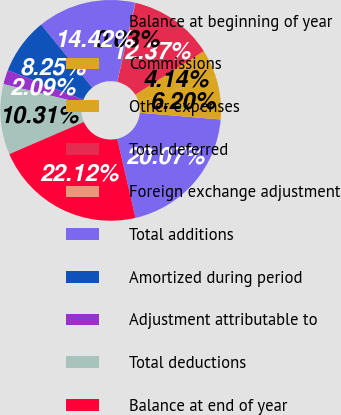Convert chart. <chart><loc_0><loc_0><loc_500><loc_500><pie_chart><fcel>Balance at beginning of year<fcel>Commissions<fcel>Other expenses<fcel>Total deferred<fcel>Foreign exchange adjustment<fcel>Total additions<fcel>Amortized during period<fcel>Adjustment attributable to<fcel>Total deductions<fcel>Balance at end of year<nl><fcel>20.07%<fcel>6.2%<fcel>4.14%<fcel>12.37%<fcel>0.03%<fcel>14.42%<fcel>8.25%<fcel>2.09%<fcel>10.31%<fcel>22.12%<nl></chart> 